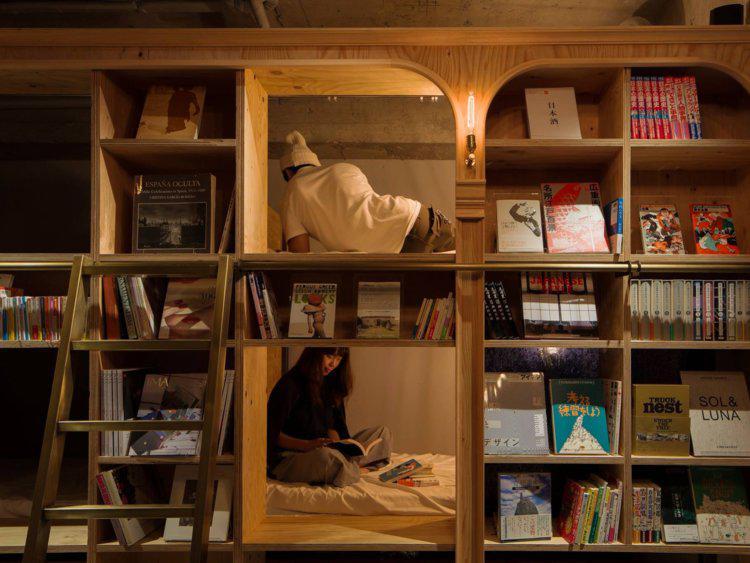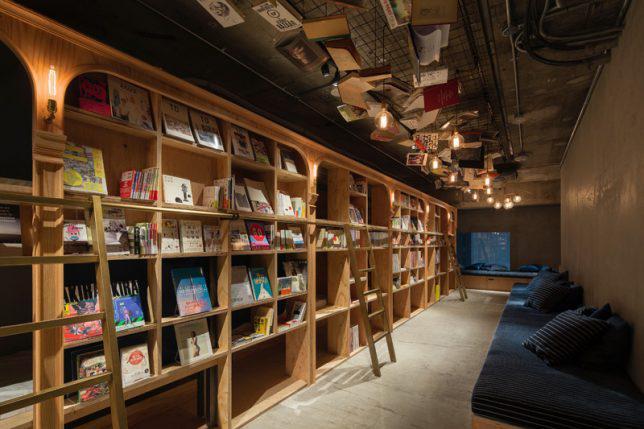The first image is the image on the left, the second image is the image on the right. Considering the images on both sides, is "There is someone sitting on a blue cushion." valid? Answer yes or no. No. The first image is the image on the left, the second image is the image on the right. Assess this claim about the two images: "In at least one image there is a blue couch facing left on the right with a person with dark hair sitting in the farthest cushing away.". Correct or not? Answer yes or no. No. 